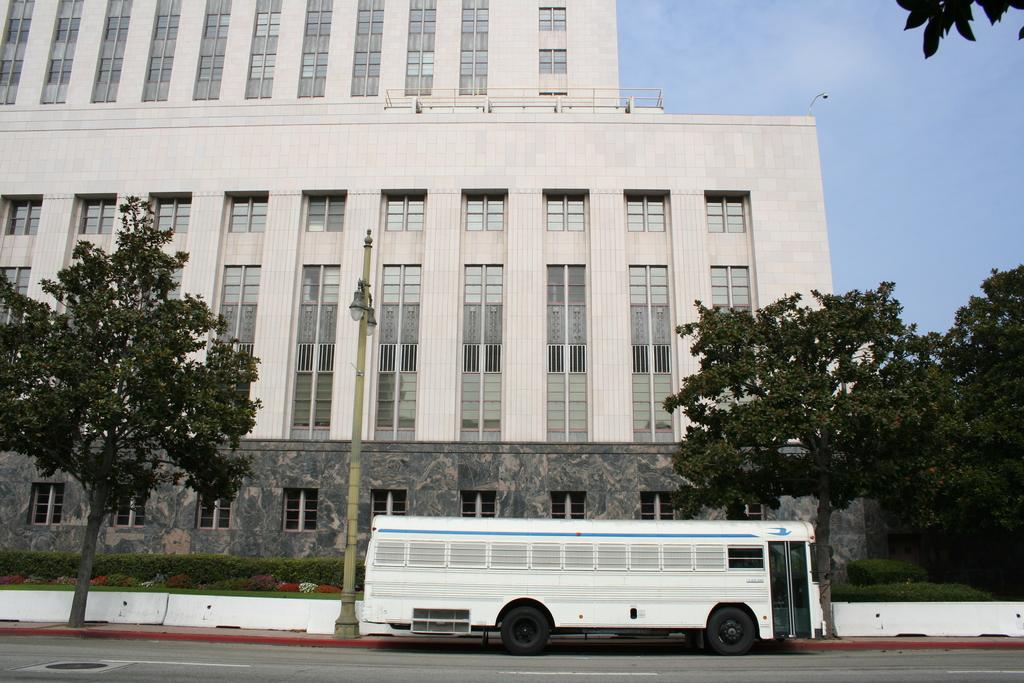What type of structure is visible in the image? There is a building in the image. What is located in front of the building? There are trees in front of the building. What is present between the trees and the building? There is a street light in front of the trees. What else can be seen on the road in front of the trees? There is a bus on the road in front of the trees. What type of eggnog is being served at the building in the image? There is no mention of eggnog or any food or beverage in the image. 